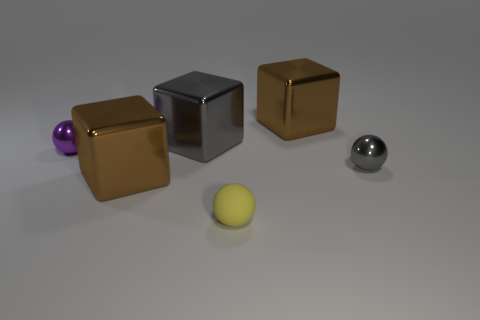There is a gray cube that is the same material as the purple ball; what is its size?
Make the answer very short. Large. Are there fewer matte balls than tiny brown matte balls?
Ensure brevity in your answer.  No. Is the tiny yellow object made of the same material as the tiny purple sphere?
Your answer should be compact. No. There is a small ball behind the tiny gray metal ball; how many gray metal things are in front of it?
Provide a succinct answer. 1. What color is the other shiny sphere that is the same size as the gray metallic ball?
Give a very brief answer. Purple. There is a ball that is in front of the tiny gray object; what material is it?
Ensure brevity in your answer.  Rubber. There is a object that is in front of the gray shiny ball and on the left side of the big gray cube; what material is it?
Make the answer very short. Metal. Does the ball on the left side of the yellow ball have the same size as the matte thing?
Make the answer very short. Yes. What shape is the yellow rubber object?
Your answer should be very brief. Sphere. What number of big brown metal things are the same shape as the large gray shiny thing?
Provide a short and direct response. 2. 